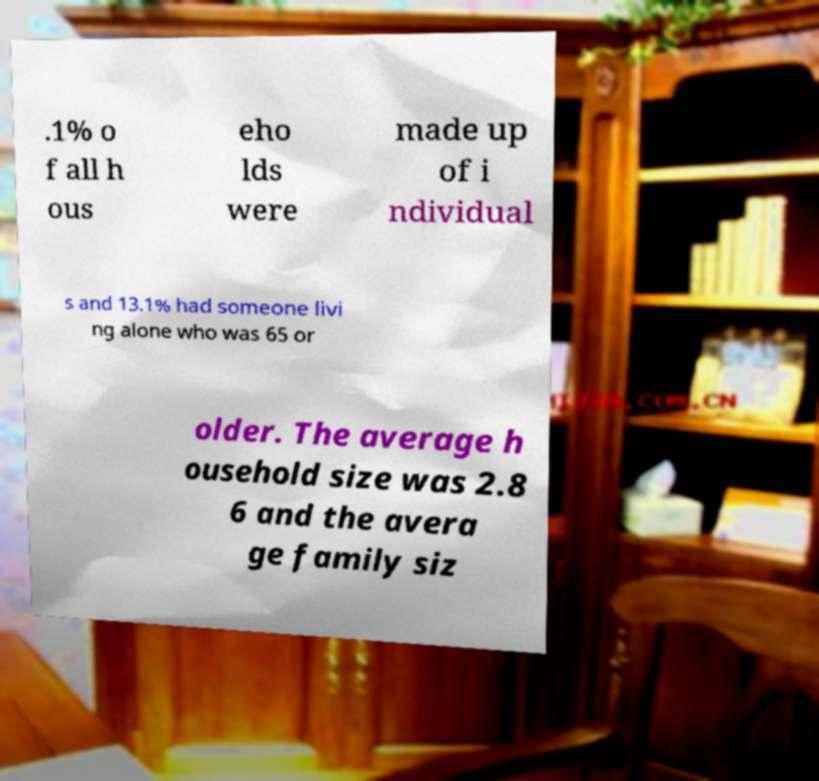For documentation purposes, I need the text within this image transcribed. Could you provide that? .1% o f all h ous eho lds were made up of i ndividual s and 13.1% had someone livi ng alone who was 65 or older. The average h ousehold size was 2.8 6 and the avera ge family siz 